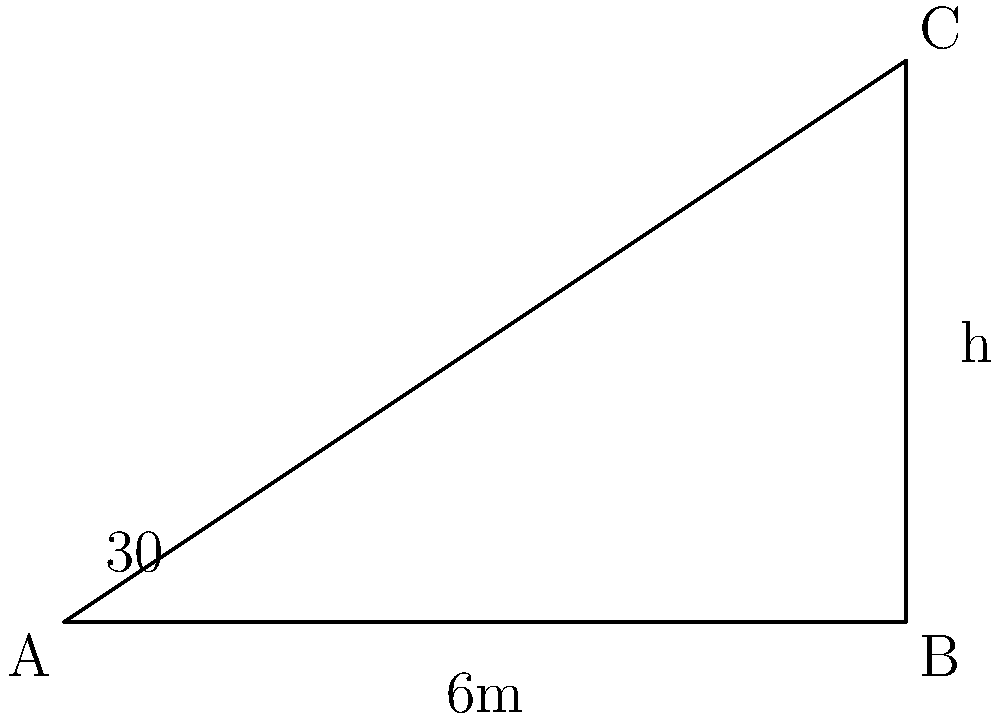In your TV studio, you're setting up lighting for a new show. A tall light stand casts a shadow on the studio floor. If the angle of elevation of the sun is 30°, and the shadow extends 6 meters from the base of the stand, what is the height of the light stand? Round your answer to the nearest tenth of a meter. Let's approach this step-by-step:

1) First, we need to identify the trigonometric relationship in this problem. We have a right triangle where:
   - The adjacent side is the length of the shadow (6 meters)
   - The opposite side is the height of the light stand (what we're solving for)
   - The angle given is 30° (the angle of elevation of the sun)

2) The trigonometric ratio that relates the opposite side to the adjacent side is the tangent (tan).

3) We can set up the equation:
   $\tan(30°) = \frac{\text{opposite}}{\text{adjacent}} = \frac{\text{height}}{6}$

4) We know that $\tan(30°) = \frac{1}{\sqrt{3}} \approx 0.577$

5) Substituting this into our equation:
   $0.577 = \frac{\text{height}}{6}$

6) To solve for height, we multiply both sides by 6:
   $\text{height} = 0.577 \times 6 = 3.462$ meters

7) Rounding to the nearest tenth:
   $\text{height} \approx 3.5$ meters
Answer: 3.5 meters 